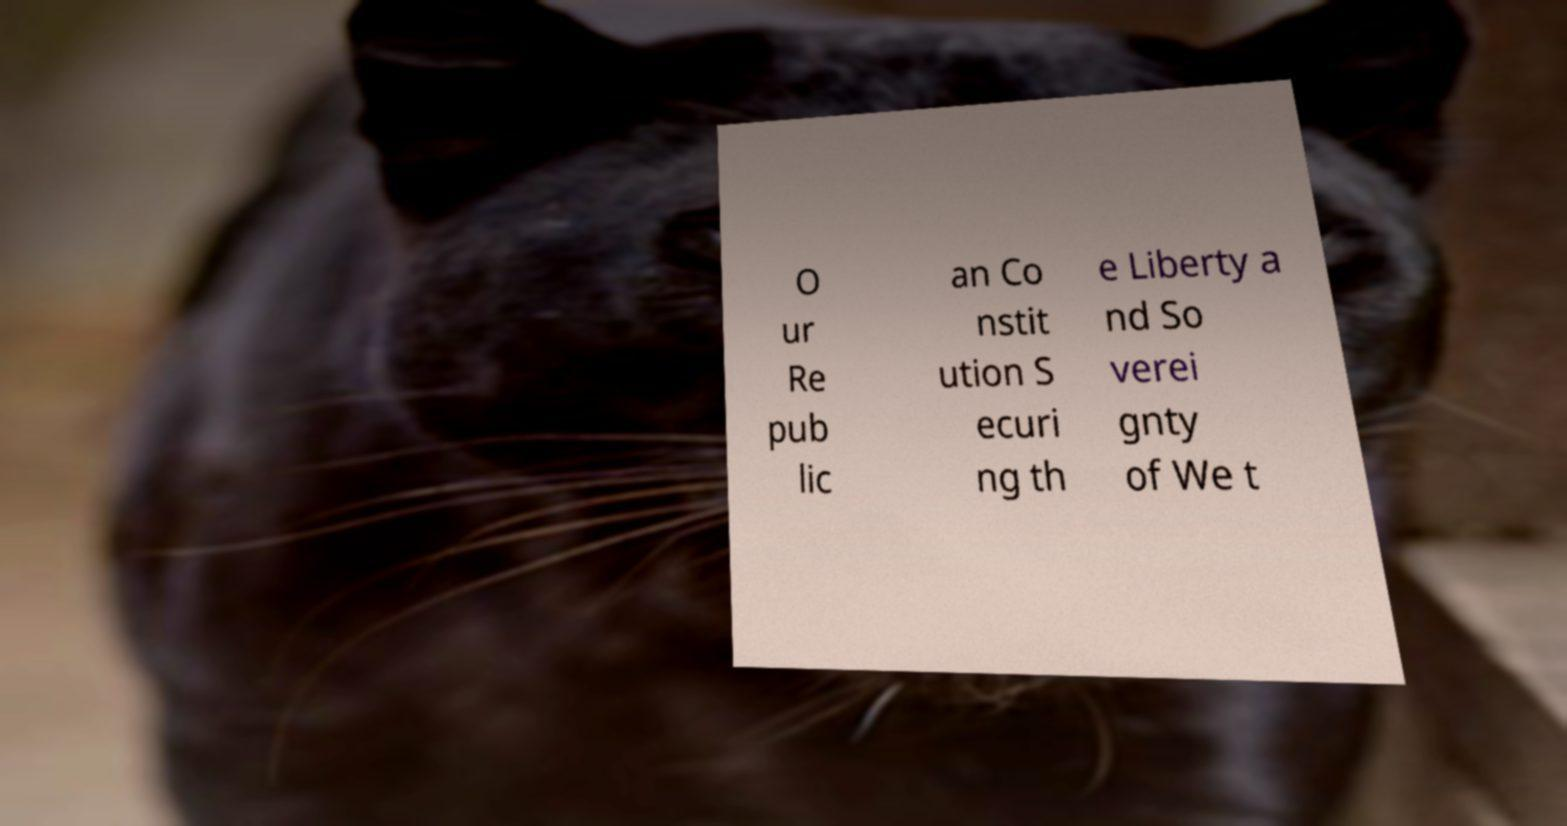Could you assist in decoding the text presented in this image and type it out clearly? O ur Re pub lic an Co nstit ution S ecuri ng th e Liberty a nd So verei gnty of We t 